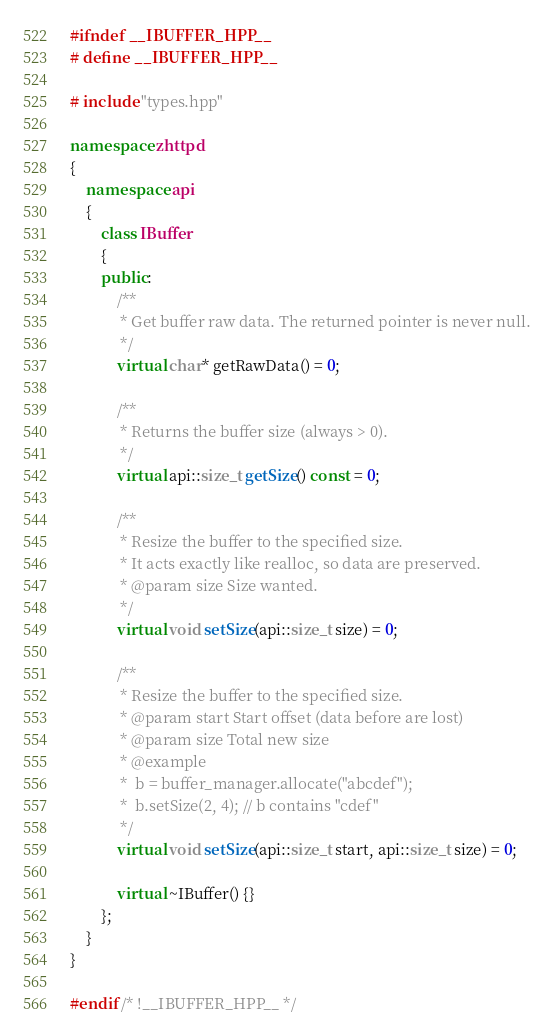<code> <loc_0><loc_0><loc_500><loc_500><_C++_>
#ifndef __IBUFFER_HPP__
# define __IBUFFER_HPP__

# include "types.hpp"

namespace zhttpd
{
    namespace api
    {
        class IBuffer
        {
        public:
            /**
             * Get buffer raw data. The returned pointer is never null.
             */
            virtual char* getRawData() = 0;

            /**
             * Returns the buffer size (always > 0).
             */
            virtual api::size_t getSize() const = 0;

            /**
             * Resize the buffer to the specified size.
             * It acts exactly like realloc, so data are preserved.
             * @param size Size wanted.
             */
            virtual void setSize(api::size_t size) = 0;

            /**
             * Resize the buffer to the specified size.
             * @param start Start offset (data before are lost)
             * @param size Total new size
             * @example
             *  b = buffer_manager.allocate("abcdef");
             *  b.setSize(2, 4); // b contains "cdef"
             */
            virtual void setSize(api::size_t start, api::size_t size) = 0;

            virtual ~IBuffer() {}
        };
    }
}

#endif /* !__IBUFFER_HPP__ */

</code> 